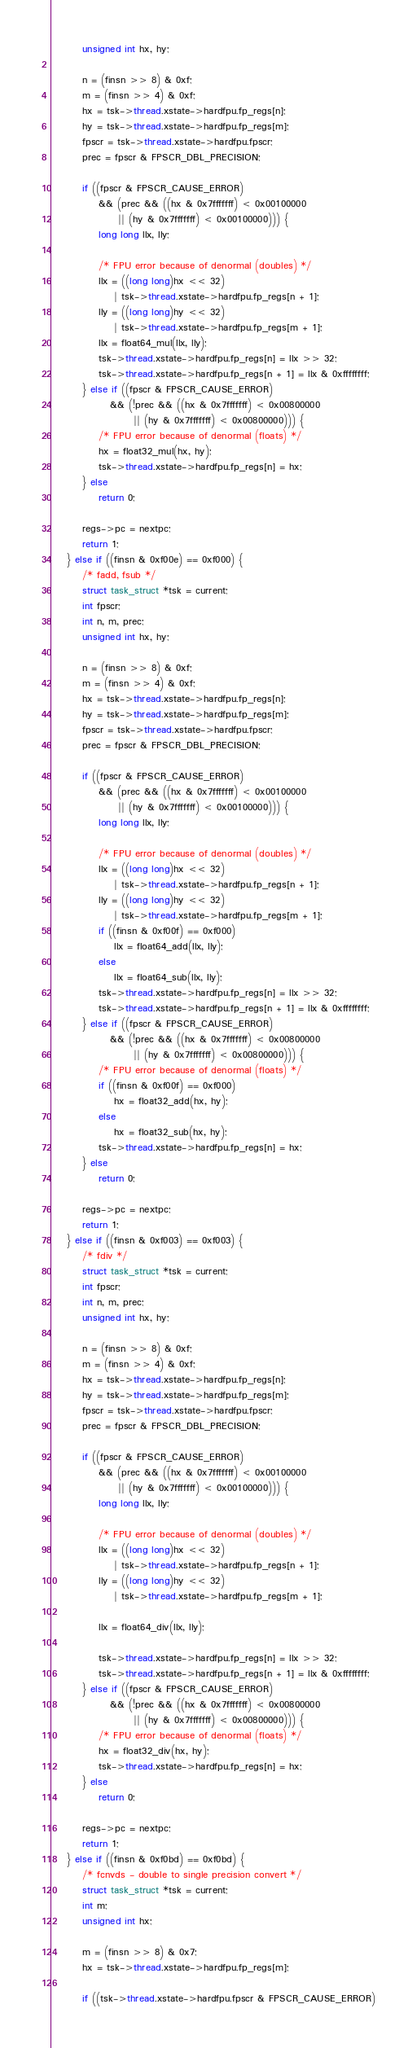<code> <loc_0><loc_0><loc_500><loc_500><_C_>		unsigned int hx, hy;

		n = (finsn >> 8) & 0xf;
		m = (finsn >> 4) & 0xf;
		hx = tsk->thread.xstate->hardfpu.fp_regs[n];
		hy = tsk->thread.xstate->hardfpu.fp_regs[m];
		fpscr = tsk->thread.xstate->hardfpu.fpscr;
		prec = fpscr & FPSCR_DBL_PRECISION;

		if ((fpscr & FPSCR_CAUSE_ERROR)
		    && (prec && ((hx & 0x7fffffff) < 0x00100000
				 || (hy & 0x7fffffff) < 0x00100000))) {
			long long llx, lly;

			/* FPU error because of denormal (doubles) */
			llx = ((long long)hx << 32)
			    | tsk->thread.xstate->hardfpu.fp_regs[n + 1];
			lly = ((long long)hy << 32)
			    | tsk->thread.xstate->hardfpu.fp_regs[m + 1];
			llx = float64_mul(llx, lly);
			tsk->thread.xstate->hardfpu.fp_regs[n] = llx >> 32;
			tsk->thread.xstate->hardfpu.fp_regs[n + 1] = llx & 0xffffffff;
		} else if ((fpscr & FPSCR_CAUSE_ERROR)
			   && (!prec && ((hx & 0x7fffffff) < 0x00800000
					 || (hy & 0x7fffffff) < 0x00800000))) {
			/* FPU error because of denormal (floats) */
			hx = float32_mul(hx, hy);
			tsk->thread.xstate->hardfpu.fp_regs[n] = hx;
		} else
			return 0;

		regs->pc = nextpc;
		return 1;
	} else if ((finsn & 0xf00e) == 0xf000) {
		/* fadd, fsub */
		struct task_struct *tsk = current;
		int fpscr;
		int n, m, prec;
		unsigned int hx, hy;

		n = (finsn >> 8) & 0xf;
		m = (finsn >> 4) & 0xf;
		hx = tsk->thread.xstate->hardfpu.fp_regs[n];
		hy = tsk->thread.xstate->hardfpu.fp_regs[m];
		fpscr = tsk->thread.xstate->hardfpu.fpscr;
		prec = fpscr & FPSCR_DBL_PRECISION;

		if ((fpscr & FPSCR_CAUSE_ERROR)
		    && (prec && ((hx & 0x7fffffff) < 0x00100000
				 || (hy & 0x7fffffff) < 0x00100000))) {
			long long llx, lly;

			/* FPU error because of denormal (doubles) */
			llx = ((long long)hx << 32)
			    | tsk->thread.xstate->hardfpu.fp_regs[n + 1];
			lly = ((long long)hy << 32)
			    | tsk->thread.xstate->hardfpu.fp_regs[m + 1];
			if ((finsn & 0xf00f) == 0xf000)
				llx = float64_add(llx, lly);
			else
				llx = float64_sub(llx, lly);
			tsk->thread.xstate->hardfpu.fp_regs[n] = llx >> 32;
			tsk->thread.xstate->hardfpu.fp_regs[n + 1] = llx & 0xffffffff;
		} else if ((fpscr & FPSCR_CAUSE_ERROR)
			   && (!prec && ((hx & 0x7fffffff) < 0x00800000
					 || (hy & 0x7fffffff) < 0x00800000))) {
			/* FPU error because of denormal (floats) */
			if ((finsn & 0xf00f) == 0xf000)
				hx = float32_add(hx, hy);
			else
				hx = float32_sub(hx, hy);
			tsk->thread.xstate->hardfpu.fp_regs[n] = hx;
		} else
			return 0;

		regs->pc = nextpc;
		return 1;
	} else if ((finsn & 0xf003) == 0xf003) {
		/* fdiv */
		struct task_struct *tsk = current;
		int fpscr;
		int n, m, prec;
		unsigned int hx, hy;

		n = (finsn >> 8) & 0xf;
		m = (finsn >> 4) & 0xf;
		hx = tsk->thread.xstate->hardfpu.fp_regs[n];
		hy = tsk->thread.xstate->hardfpu.fp_regs[m];
		fpscr = tsk->thread.xstate->hardfpu.fpscr;
		prec = fpscr & FPSCR_DBL_PRECISION;

		if ((fpscr & FPSCR_CAUSE_ERROR)
		    && (prec && ((hx & 0x7fffffff) < 0x00100000
				 || (hy & 0x7fffffff) < 0x00100000))) {
			long long llx, lly;

			/* FPU error because of denormal (doubles) */
			llx = ((long long)hx << 32)
			    | tsk->thread.xstate->hardfpu.fp_regs[n + 1];
			lly = ((long long)hy << 32)
			    | tsk->thread.xstate->hardfpu.fp_regs[m + 1];

			llx = float64_div(llx, lly);

			tsk->thread.xstate->hardfpu.fp_regs[n] = llx >> 32;
			tsk->thread.xstate->hardfpu.fp_regs[n + 1] = llx & 0xffffffff;
		} else if ((fpscr & FPSCR_CAUSE_ERROR)
			   && (!prec && ((hx & 0x7fffffff) < 0x00800000
					 || (hy & 0x7fffffff) < 0x00800000))) {
			/* FPU error because of denormal (floats) */
			hx = float32_div(hx, hy);
			tsk->thread.xstate->hardfpu.fp_regs[n] = hx;
		} else
			return 0;

		regs->pc = nextpc;
		return 1;
	} else if ((finsn & 0xf0bd) == 0xf0bd) {
		/* fcnvds - double to single precision convert */
		struct task_struct *tsk = current;
		int m;
		unsigned int hx;

		m = (finsn >> 8) & 0x7;
		hx = tsk->thread.xstate->hardfpu.fp_regs[m];

		if ((tsk->thread.xstate->hardfpu.fpscr & FPSCR_CAUSE_ERROR)</code> 